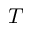<formula> <loc_0><loc_0><loc_500><loc_500>T</formula> 